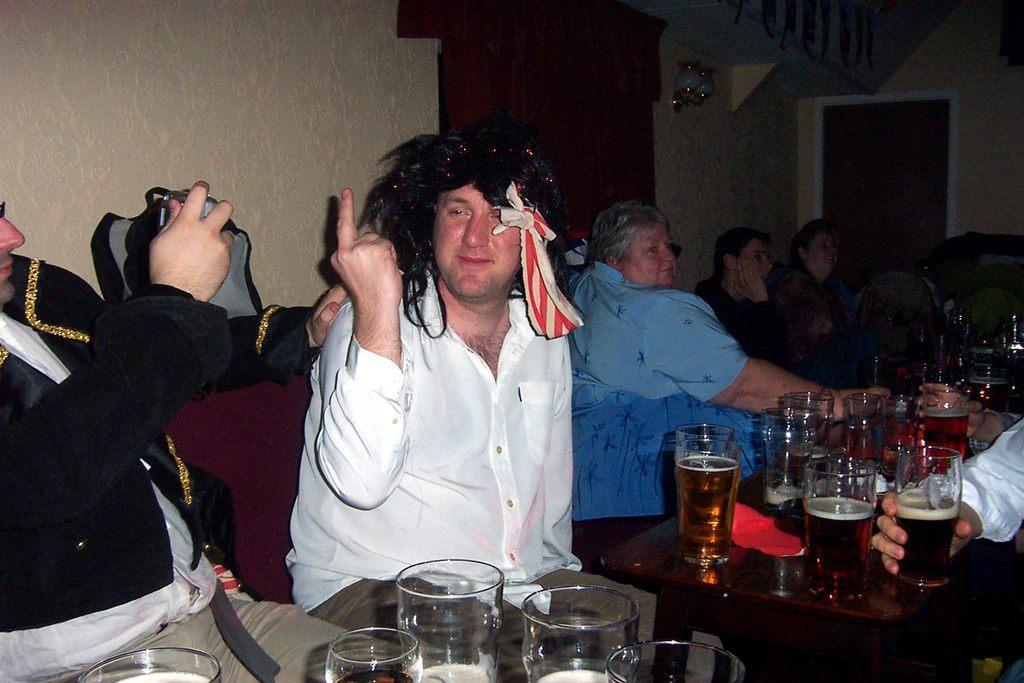Can you describe this image briefly? In this image we can see many people. There are many drink glasses placed on the tables. A person is holding an object at the left side of the image. There are lamps on the wall. There is a curtain in the image. There is a door at the right side of the image. 